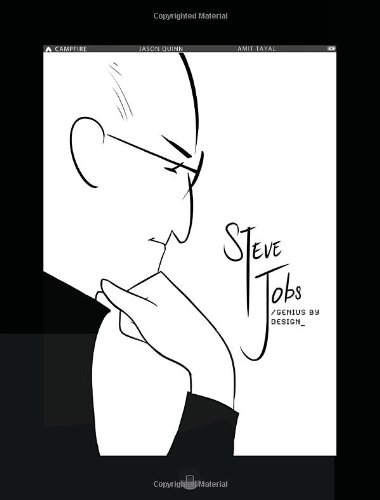Is this a child-care book? No, this book is not focused on child-care; rather, it's a biographical account of Steve Jobs, crafted to inspire through graphic storytelling. 